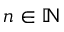Convert formula to latex. <formula><loc_0><loc_0><loc_500><loc_500>n \in \mathbb { N }</formula> 